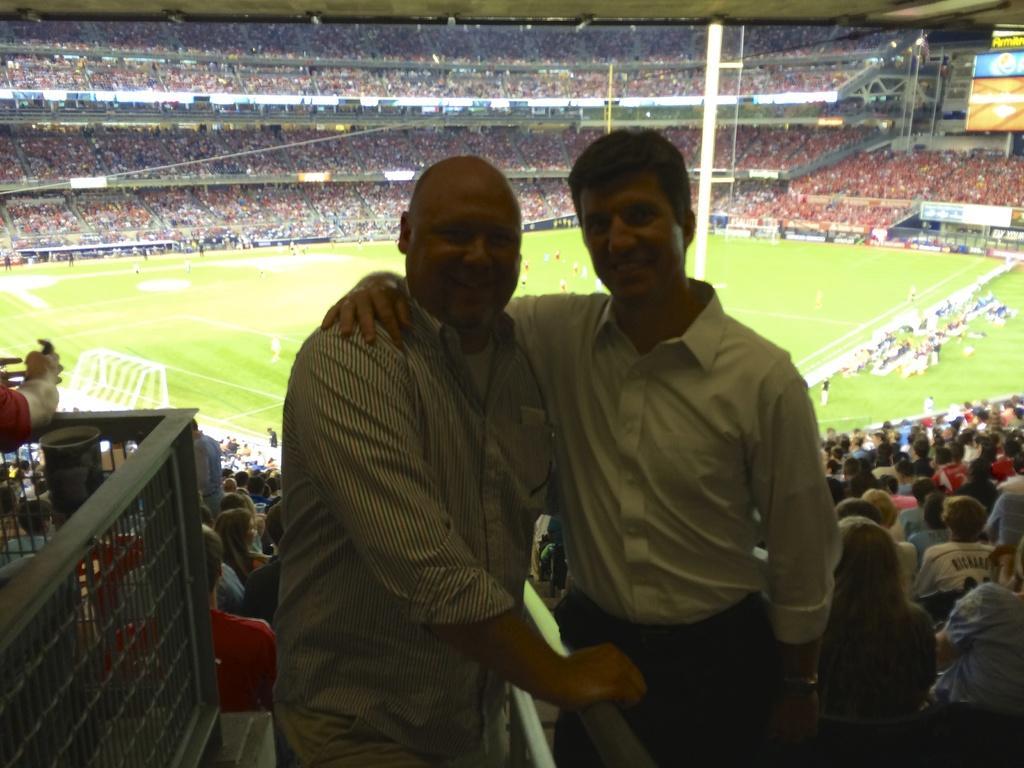Please provide a concise description of this image. This is a picture of a stadium. In the background we can see crowd. In the top right corner of the picture, it seems like a screen. We can see men standing and they both are smiling. On the ground we can see people. On the right and left side of the picture we can see people. On the left side we can see a person. 